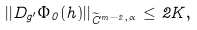<formula> <loc_0><loc_0><loc_500><loc_500>| | D _ { g ^ { \prime } } \Phi _ { 0 } ( h ) | | _ { \widetilde { C } ^ { m - 2 , \alpha } } \leq 2 K ,</formula> 